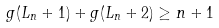<formula> <loc_0><loc_0><loc_500><loc_500>g ( L _ { n } + 1 ) + g ( L _ { n } + 2 ) \geq n + 1</formula> 